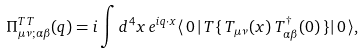<formula> <loc_0><loc_0><loc_500><loc_500>\Pi ^ { T T } _ { \mu \nu ; \alpha \beta } ( q ) = i \int d ^ { 4 } x \, e ^ { i q \cdot x } \langle \, 0 \, | \, T \{ \, T _ { \mu \nu } ( x ) \, T _ { \alpha \beta } ^ { \dagger } ( 0 ) \, \} | \, 0 \, \rangle ,</formula> 